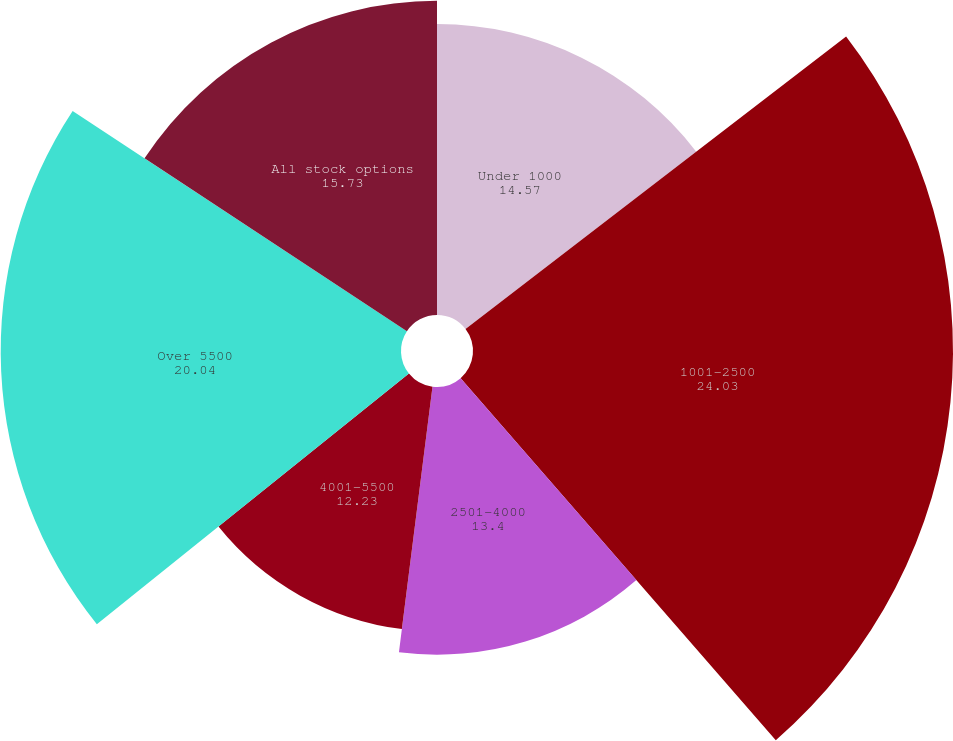Convert chart to OTSL. <chart><loc_0><loc_0><loc_500><loc_500><pie_chart><fcel>Under 1000<fcel>1001-2500<fcel>2501-4000<fcel>4001-5500<fcel>Over 5500<fcel>All stock options<nl><fcel>14.57%<fcel>24.03%<fcel>13.4%<fcel>12.23%<fcel>20.04%<fcel>15.73%<nl></chart> 